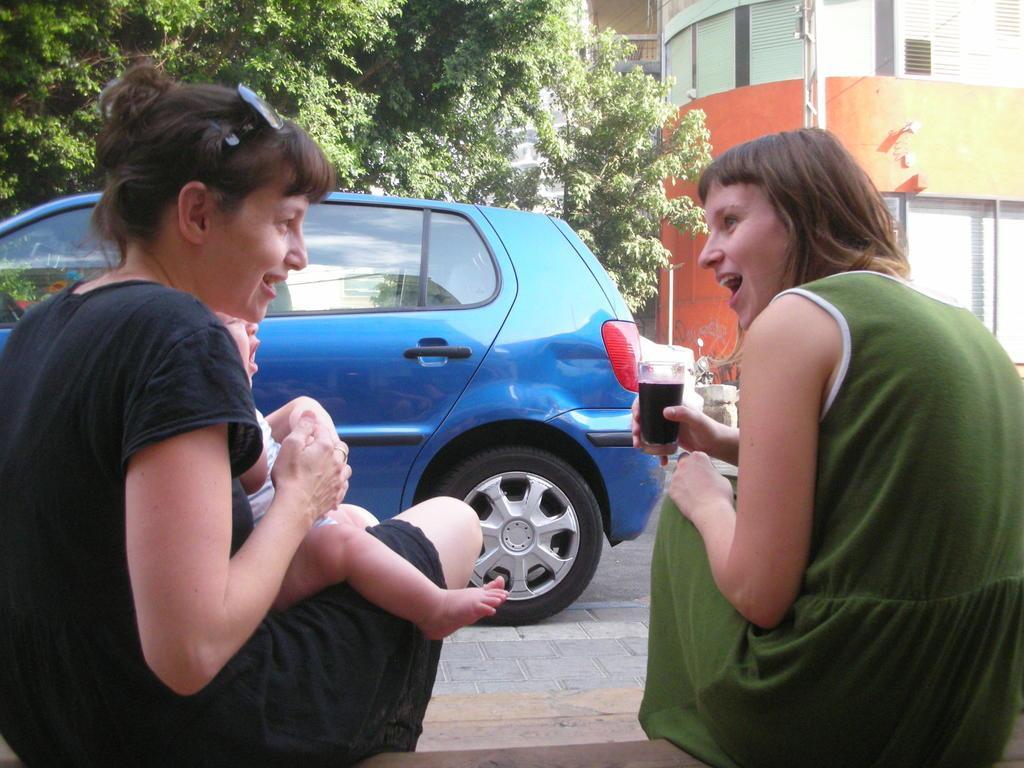In one or two sentences, can you explain what this image depicts? In this picture I can see 2 women in front and I see that, the woman on the right is holding a glass and the woman on the left is holding a baby. In the background I can see the path, on which there is a blue color car and behind the car I can see the trees and a building. 